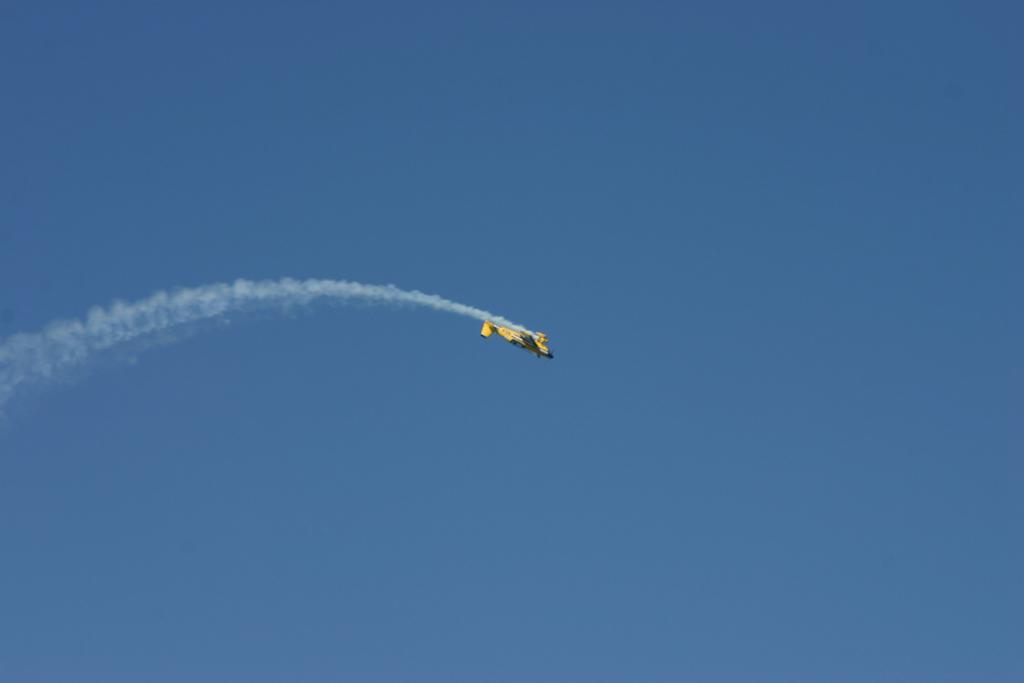What is the main subject of the image? The main subject of the image is an airplane. What is the airplane doing in the image? The airplane is flying in the air and releasing smoke. What can be seen in the background of the image? There is sky visible in the background of the image. What type of base can be seen supporting the airplane in the image? There is no base supporting the airplane in the image; it is flying in the air. 